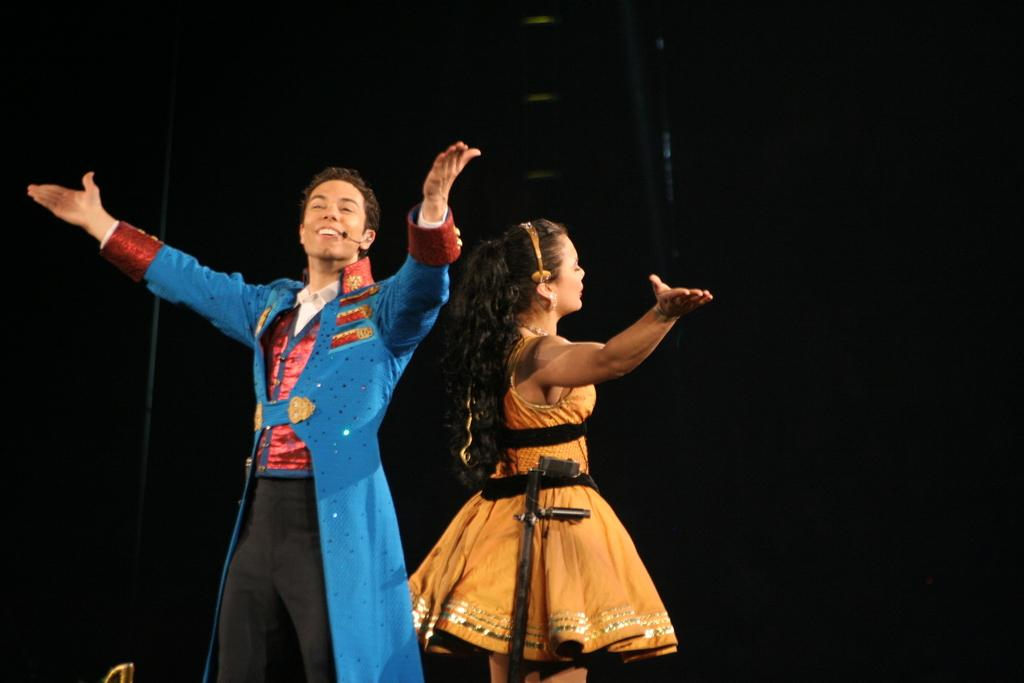How many people are in the image? There are two people standing in the image. What else can be seen in the image besides the people? There are objects present in the image. Can you describe the background of the image? The background of the image is dark. What type of kettle is visible in the image? There is no kettle present in the image. What route are the people taking in the image? The image does not show the people taking any specific route, as they are standing still. 